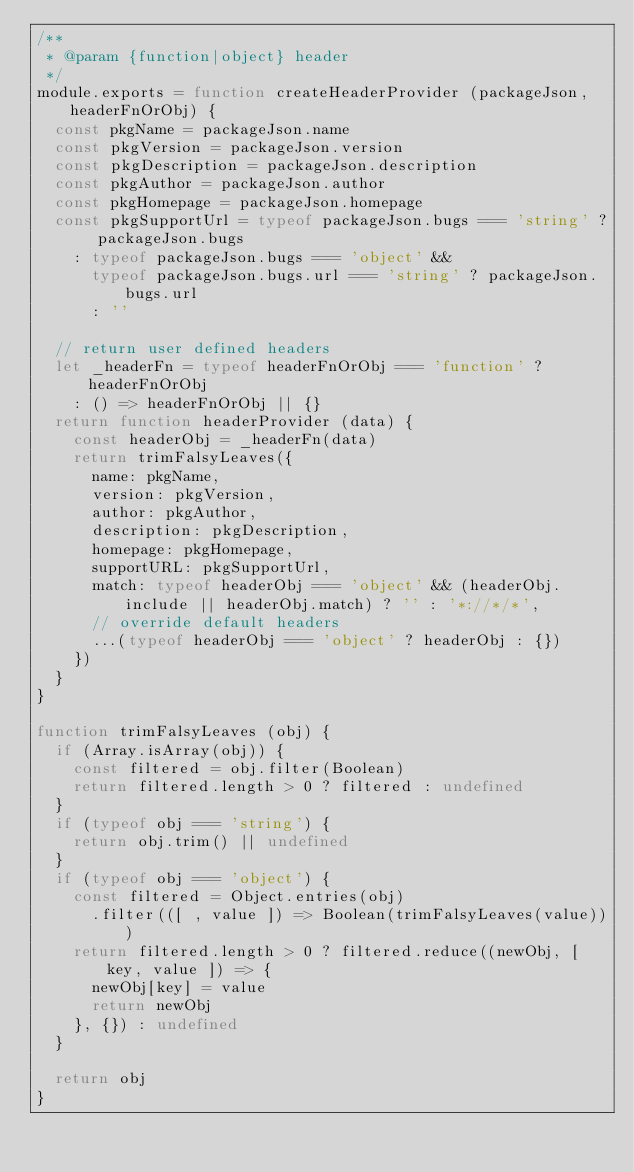<code> <loc_0><loc_0><loc_500><loc_500><_JavaScript_>/**
 * @param {function|object} header
 */
module.exports = function createHeaderProvider (packageJson, headerFnOrObj) {
  const pkgName = packageJson.name
  const pkgVersion = packageJson.version
  const pkgDescription = packageJson.description
  const pkgAuthor = packageJson.author
  const pkgHomepage = packageJson.homepage
  const pkgSupportUrl = typeof packageJson.bugs === 'string' ? packageJson.bugs
    : typeof packageJson.bugs === 'object' &&
      typeof packageJson.bugs.url === 'string' ? packageJson.bugs.url
      : ''

  // return user defined headers
  let _headerFn = typeof headerFnOrObj === 'function' ? headerFnOrObj
    : () => headerFnOrObj || {}
  return function headerProvider (data) {
    const headerObj = _headerFn(data)
    return trimFalsyLeaves({
      name: pkgName,
      version: pkgVersion,
      author: pkgAuthor,
      description: pkgDescription,
      homepage: pkgHomepage,
      supportURL: pkgSupportUrl,
      match: typeof headerObj === 'object' && (headerObj.include || headerObj.match) ? '' : '*://*/*',
      // override default headers
      ...(typeof headerObj === 'object' ? headerObj : {})
    })
  }
}

function trimFalsyLeaves (obj) {
  if (Array.isArray(obj)) {
    const filtered = obj.filter(Boolean)
    return filtered.length > 0 ? filtered : undefined
  }
  if (typeof obj === 'string') {
    return obj.trim() || undefined
  }
  if (typeof obj === 'object') {
    const filtered = Object.entries(obj)
      .filter(([ , value ]) => Boolean(trimFalsyLeaves(value)))
    return filtered.length > 0 ? filtered.reduce((newObj, [ key, value ]) => {
      newObj[key] = value
      return newObj
    }, {}) : undefined
  }

  return obj
}
</code> 